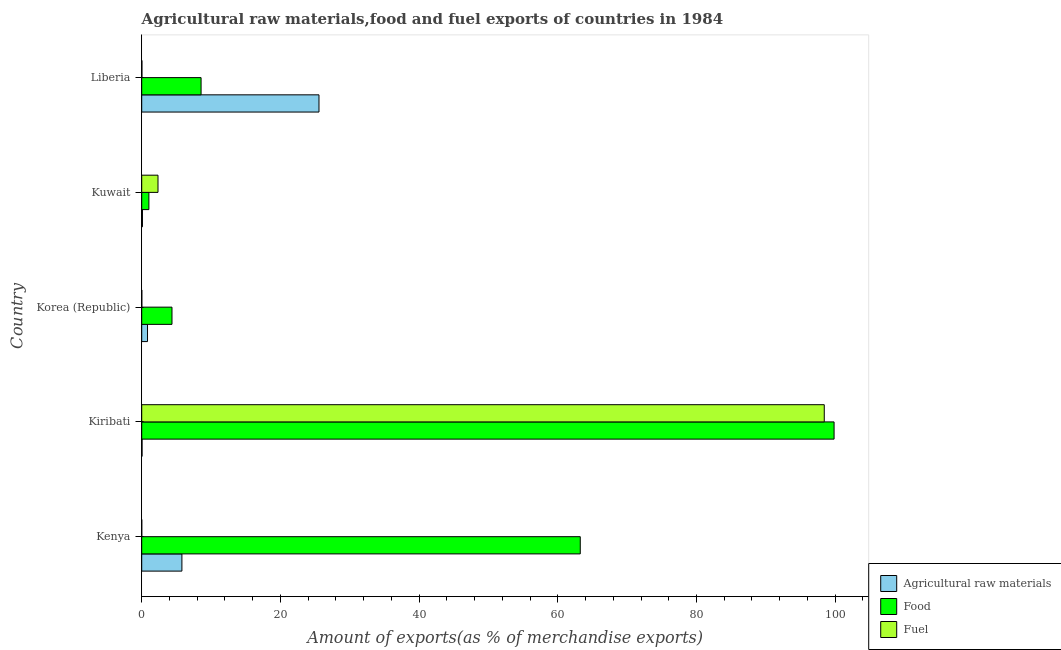Are the number of bars per tick equal to the number of legend labels?
Give a very brief answer. Yes. Are the number of bars on each tick of the Y-axis equal?
Provide a succinct answer. Yes. What is the label of the 1st group of bars from the top?
Provide a succinct answer. Liberia. What is the percentage of food exports in Kenya?
Keep it short and to the point. 63.24. Across all countries, what is the maximum percentage of food exports?
Your answer should be compact. 99.84. Across all countries, what is the minimum percentage of raw materials exports?
Offer a terse response. 0.05. In which country was the percentage of raw materials exports maximum?
Ensure brevity in your answer.  Liberia. In which country was the percentage of raw materials exports minimum?
Provide a succinct answer. Kiribati. What is the total percentage of food exports in the graph?
Offer a terse response. 177.03. What is the difference between the percentage of raw materials exports in Korea (Republic) and that in Kuwait?
Offer a terse response. 0.73. What is the difference between the percentage of raw materials exports in Korea (Republic) and the percentage of food exports in Kiribati?
Make the answer very short. -99. What is the average percentage of food exports per country?
Make the answer very short. 35.41. What is the difference between the percentage of fuel exports and percentage of raw materials exports in Kuwait?
Your response must be concise. 2.24. In how many countries, is the percentage of fuel exports greater than 28 %?
Offer a very short reply. 1. What is the ratio of the percentage of food exports in Korea (Republic) to that in Liberia?
Your response must be concise. 0.51. What is the difference between the highest and the second highest percentage of food exports?
Your answer should be very brief. 36.6. What is the difference between the highest and the lowest percentage of raw materials exports?
Offer a terse response. 25.51. In how many countries, is the percentage of food exports greater than the average percentage of food exports taken over all countries?
Give a very brief answer. 2. Is the sum of the percentage of food exports in Kenya and Korea (Republic) greater than the maximum percentage of raw materials exports across all countries?
Your answer should be very brief. Yes. What does the 3rd bar from the top in Liberia represents?
Your answer should be very brief. Agricultural raw materials. What does the 3rd bar from the bottom in Korea (Republic) represents?
Ensure brevity in your answer.  Fuel. How many bars are there?
Your answer should be very brief. 15. Are all the bars in the graph horizontal?
Give a very brief answer. Yes. How many countries are there in the graph?
Offer a very short reply. 5. Are the values on the major ticks of X-axis written in scientific E-notation?
Make the answer very short. No. Does the graph contain any zero values?
Provide a succinct answer. No. Does the graph contain grids?
Offer a terse response. No. Where does the legend appear in the graph?
Provide a short and direct response. Bottom right. How many legend labels are there?
Your response must be concise. 3. What is the title of the graph?
Provide a succinct answer. Agricultural raw materials,food and fuel exports of countries in 1984. Does "Nuclear sources" appear as one of the legend labels in the graph?
Give a very brief answer. No. What is the label or title of the X-axis?
Provide a short and direct response. Amount of exports(as % of merchandise exports). What is the Amount of exports(as % of merchandise exports) of Agricultural raw materials in Kenya?
Ensure brevity in your answer.  5.79. What is the Amount of exports(as % of merchandise exports) of Food in Kenya?
Give a very brief answer. 63.24. What is the Amount of exports(as % of merchandise exports) in Fuel in Kenya?
Give a very brief answer. 0. What is the Amount of exports(as % of merchandise exports) of Agricultural raw materials in Kiribati?
Provide a short and direct response. 0.05. What is the Amount of exports(as % of merchandise exports) of Food in Kiribati?
Offer a very short reply. 99.84. What is the Amount of exports(as % of merchandise exports) in Fuel in Kiribati?
Your response must be concise. 98.42. What is the Amount of exports(as % of merchandise exports) in Agricultural raw materials in Korea (Republic)?
Offer a terse response. 0.84. What is the Amount of exports(as % of merchandise exports) in Food in Korea (Republic)?
Keep it short and to the point. 4.36. What is the Amount of exports(as % of merchandise exports) of Fuel in Korea (Republic)?
Your response must be concise. 0.01. What is the Amount of exports(as % of merchandise exports) in Agricultural raw materials in Kuwait?
Make the answer very short. 0.11. What is the Amount of exports(as % of merchandise exports) in Food in Kuwait?
Your response must be concise. 1.03. What is the Amount of exports(as % of merchandise exports) in Fuel in Kuwait?
Offer a terse response. 2.35. What is the Amount of exports(as % of merchandise exports) of Agricultural raw materials in Liberia?
Provide a succinct answer. 25.56. What is the Amount of exports(as % of merchandise exports) of Food in Liberia?
Offer a terse response. 8.56. What is the Amount of exports(as % of merchandise exports) in Fuel in Liberia?
Your answer should be compact. 0.03. Across all countries, what is the maximum Amount of exports(as % of merchandise exports) in Agricultural raw materials?
Make the answer very short. 25.56. Across all countries, what is the maximum Amount of exports(as % of merchandise exports) in Food?
Your answer should be compact. 99.84. Across all countries, what is the maximum Amount of exports(as % of merchandise exports) in Fuel?
Your answer should be compact. 98.42. Across all countries, what is the minimum Amount of exports(as % of merchandise exports) of Agricultural raw materials?
Keep it short and to the point. 0.05. Across all countries, what is the minimum Amount of exports(as % of merchandise exports) in Food?
Make the answer very short. 1.03. Across all countries, what is the minimum Amount of exports(as % of merchandise exports) of Fuel?
Give a very brief answer. 0. What is the total Amount of exports(as % of merchandise exports) in Agricultural raw materials in the graph?
Offer a terse response. 32.35. What is the total Amount of exports(as % of merchandise exports) in Food in the graph?
Ensure brevity in your answer.  177.03. What is the total Amount of exports(as % of merchandise exports) in Fuel in the graph?
Ensure brevity in your answer.  100.82. What is the difference between the Amount of exports(as % of merchandise exports) in Agricultural raw materials in Kenya and that in Kiribati?
Offer a very short reply. 5.75. What is the difference between the Amount of exports(as % of merchandise exports) of Food in Kenya and that in Kiribati?
Keep it short and to the point. -36.6. What is the difference between the Amount of exports(as % of merchandise exports) of Fuel in Kenya and that in Kiribati?
Your answer should be compact. -98.42. What is the difference between the Amount of exports(as % of merchandise exports) of Agricultural raw materials in Kenya and that in Korea (Republic)?
Keep it short and to the point. 4.96. What is the difference between the Amount of exports(as % of merchandise exports) in Food in Kenya and that in Korea (Republic)?
Provide a short and direct response. 58.87. What is the difference between the Amount of exports(as % of merchandise exports) of Fuel in Kenya and that in Korea (Republic)?
Your answer should be compact. -0.01. What is the difference between the Amount of exports(as % of merchandise exports) of Agricultural raw materials in Kenya and that in Kuwait?
Give a very brief answer. 5.69. What is the difference between the Amount of exports(as % of merchandise exports) in Food in Kenya and that in Kuwait?
Ensure brevity in your answer.  62.2. What is the difference between the Amount of exports(as % of merchandise exports) in Fuel in Kenya and that in Kuwait?
Your answer should be compact. -2.34. What is the difference between the Amount of exports(as % of merchandise exports) in Agricultural raw materials in Kenya and that in Liberia?
Your answer should be very brief. -19.77. What is the difference between the Amount of exports(as % of merchandise exports) of Food in Kenya and that in Liberia?
Give a very brief answer. 54.68. What is the difference between the Amount of exports(as % of merchandise exports) in Fuel in Kenya and that in Liberia?
Make the answer very short. -0.02. What is the difference between the Amount of exports(as % of merchandise exports) in Agricultural raw materials in Kiribati and that in Korea (Republic)?
Ensure brevity in your answer.  -0.79. What is the difference between the Amount of exports(as % of merchandise exports) in Food in Kiribati and that in Korea (Republic)?
Your answer should be compact. 95.47. What is the difference between the Amount of exports(as % of merchandise exports) in Fuel in Kiribati and that in Korea (Republic)?
Offer a terse response. 98.41. What is the difference between the Amount of exports(as % of merchandise exports) of Agricultural raw materials in Kiribati and that in Kuwait?
Your answer should be compact. -0.06. What is the difference between the Amount of exports(as % of merchandise exports) of Food in Kiribati and that in Kuwait?
Provide a short and direct response. 98.8. What is the difference between the Amount of exports(as % of merchandise exports) of Fuel in Kiribati and that in Kuwait?
Your answer should be compact. 96.08. What is the difference between the Amount of exports(as % of merchandise exports) of Agricultural raw materials in Kiribati and that in Liberia?
Your answer should be very brief. -25.51. What is the difference between the Amount of exports(as % of merchandise exports) in Food in Kiribati and that in Liberia?
Provide a succinct answer. 91.28. What is the difference between the Amount of exports(as % of merchandise exports) in Fuel in Kiribati and that in Liberia?
Your response must be concise. 98.39. What is the difference between the Amount of exports(as % of merchandise exports) in Agricultural raw materials in Korea (Republic) and that in Kuwait?
Ensure brevity in your answer.  0.73. What is the difference between the Amount of exports(as % of merchandise exports) of Food in Korea (Republic) and that in Kuwait?
Offer a very short reply. 3.33. What is the difference between the Amount of exports(as % of merchandise exports) in Fuel in Korea (Republic) and that in Kuwait?
Provide a succinct answer. -2.33. What is the difference between the Amount of exports(as % of merchandise exports) of Agricultural raw materials in Korea (Republic) and that in Liberia?
Ensure brevity in your answer.  -24.72. What is the difference between the Amount of exports(as % of merchandise exports) of Food in Korea (Republic) and that in Liberia?
Provide a short and direct response. -4.2. What is the difference between the Amount of exports(as % of merchandise exports) in Fuel in Korea (Republic) and that in Liberia?
Your response must be concise. -0.02. What is the difference between the Amount of exports(as % of merchandise exports) in Agricultural raw materials in Kuwait and that in Liberia?
Keep it short and to the point. -25.45. What is the difference between the Amount of exports(as % of merchandise exports) of Food in Kuwait and that in Liberia?
Make the answer very short. -7.53. What is the difference between the Amount of exports(as % of merchandise exports) in Fuel in Kuwait and that in Liberia?
Your answer should be very brief. 2.32. What is the difference between the Amount of exports(as % of merchandise exports) of Agricultural raw materials in Kenya and the Amount of exports(as % of merchandise exports) of Food in Kiribati?
Ensure brevity in your answer.  -94.04. What is the difference between the Amount of exports(as % of merchandise exports) of Agricultural raw materials in Kenya and the Amount of exports(as % of merchandise exports) of Fuel in Kiribati?
Give a very brief answer. -92.63. What is the difference between the Amount of exports(as % of merchandise exports) of Food in Kenya and the Amount of exports(as % of merchandise exports) of Fuel in Kiribati?
Your response must be concise. -35.19. What is the difference between the Amount of exports(as % of merchandise exports) in Agricultural raw materials in Kenya and the Amount of exports(as % of merchandise exports) in Food in Korea (Republic)?
Make the answer very short. 1.43. What is the difference between the Amount of exports(as % of merchandise exports) of Agricultural raw materials in Kenya and the Amount of exports(as % of merchandise exports) of Fuel in Korea (Republic)?
Provide a succinct answer. 5.78. What is the difference between the Amount of exports(as % of merchandise exports) in Food in Kenya and the Amount of exports(as % of merchandise exports) in Fuel in Korea (Republic)?
Keep it short and to the point. 63.23. What is the difference between the Amount of exports(as % of merchandise exports) of Agricultural raw materials in Kenya and the Amount of exports(as % of merchandise exports) of Food in Kuwait?
Offer a very short reply. 4.76. What is the difference between the Amount of exports(as % of merchandise exports) in Agricultural raw materials in Kenya and the Amount of exports(as % of merchandise exports) in Fuel in Kuwait?
Give a very brief answer. 3.45. What is the difference between the Amount of exports(as % of merchandise exports) in Food in Kenya and the Amount of exports(as % of merchandise exports) in Fuel in Kuwait?
Provide a short and direct response. 60.89. What is the difference between the Amount of exports(as % of merchandise exports) of Agricultural raw materials in Kenya and the Amount of exports(as % of merchandise exports) of Food in Liberia?
Offer a very short reply. -2.77. What is the difference between the Amount of exports(as % of merchandise exports) of Agricultural raw materials in Kenya and the Amount of exports(as % of merchandise exports) of Fuel in Liberia?
Your response must be concise. 5.77. What is the difference between the Amount of exports(as % of merchandise exports) in Food in Kenya and the Amount of exports(as % of merchandise exports) in Fuel in Liberia?
Offer a very short reply. 63.21. What is the difference between the Amount of exports(as % of merchandise exports) of Agricultural raw materials in Kiribati and the Amount of exports(as % of merchandise exports) of Food in Korea (Republic)?
Offer a very short reply. -4.32. What is the difference between the Amount of exports(as % of merchandise exports) in Agricultural raw materials in Kiribati and the Amount of exports(as % of merchandise exports) in Fuel in Korea (Republic)?
Keep it short and to the point. 0.04. What is the difference between the Amount of exports(as % of merchandise exports) of Food in Kiribati and the Amount of exports(as % of merchandise exports) of Fuel in Korea (Republic)?
Your answer should be very brief. 99.83. What is the difference between the Amount of exports(as % of merchandise exports) in Agricultural raw materials in Kiribati and the Amount of exports(as % of merchandise exports) in Food in Kuwait?
Provide a short and direct response. -0.99. What is the difference between the Amount of exports(as % of merchandise exports) of Agricultural raw materials in Kiribati and the Amount of exports(as % of merchandise exports) of Fuel in Kuwait?
Offer a very short reply. -2.3. What is the difference between the Amount of exports(as % of merchandise exports) of Food in Kiribati and the Amount of exports(as % of merchandise exports) of Fuel in Kuwait?
Your answer should be very brief. 97.49. What is the difference between the Amount of exports(as % of merchandise exports) of Agricultural raw materials in Kiribati and the Amount of exports(as % of merchandise exports) of Food in Liberia?
Offer a very short reply. -8.51. What is the difference between the Amount of exports(as % of merchandise exports) of Food in Kiribati and the Amount of exports(as % of merchandise exports) of Fuel in Liberia?
Your response must be concise. 99.81. What is the difference between the Amount of exports(as % of merchandise exports) of Agricultural raw materials in Korea (Republic) and the Amount of exports(as % of merchandise exports) of Food in Kuwait?
Keep it short and to the point. -0.2. What is the difference between the Amount of exports(as % of merchandise exports) of Agricultural raw materials in Korea (Republic) and the Amount of exports(as % of merchandise exports) of Fuel in Kuwait?
Offer a terse response. -1.51. What is the difference between the Amount of exports(as % of merchandise exports) of Food in Korea (Republic) and the Amount of exports(as % of merchandise exports) of Fuel in Kuwait?
Ensure brevity in your answer.  2.02. What is the difference between the Amount of exports(as % of merchandise exports) of Agricultural raw materials in Korea (Republic) and the Amount of exports(as % of merchandise exports) of Food in Liberia?
Your answer should be very brief. -7.72. What is the difference between the Amount of exports(as % of merchandise exports) in Agricultural raw materials in Korea (Republic) and the Amount of exports(as % of merchandise exports) in Fuel in Liberia?
Provide a succinct answer. 0.81. What is the difference between the Amount of exports(as % of merchandise exports) of Food in Korea (Republic) and the Amount of exports(as % of merchandise exports) of Fuel in Liberia?
Offer a very short reply. 4.34. What is the difference between the Amount of exports(as % of merchandise exports) in Agricultural raw materials in Kuwait and the Amount of exports(as % of merchandise exports) in Food in Liberia?
Your answer should be very brief. -8.45. What is the difference between the Amount of exports(as % of merchandise exports) of Agricultural raw materials in Kuwait and the Amount of exports(as % of merchandise exports) of Fuel in Liberia?
Offer a terse response. 0.08. What is the difference between the Amount of exports(as % of merchandise exports) of Food in Kuwait and the Amount of exports(as % of merchandise exports) of Fuel in Liberia?
Your answer should be compact. 1.01. What is the average Amount of exports(as % of merchandise exports) in Agricultural raw materials per country?
Offer a terse response. 6.47. What is the average Amount of exports(as % of merchandise exports) in Food per country?
Provide a short and direct response. 35.41. What is the average Amount of exports(as % of merchandise exports) of Fuel per country?
Provide a succinct answer. 20.16. What is the difference between the Amount of exports(as % of merchandise exports) of Agricultural raw materials and Amount of exports(as % of merchandise exports) of Food in Kenya?
Offer a terse response. -57.44. What is the difference between the Amount of exports(as % of merchandise exports) of Agricultural raw materials and Amount of exports(as % of merchandise exports) of Fuel in Kenya?
Your answer should be very brief. 5.79. What is the difference between the Amount of exports(as % of merchandise exports) in Food and Amount of exports(as % of merchandise exports) in Fuel in Kenya?
Give a very brief answer. 63.23. What is the difference between the Amount of exports(as % of merchandise exports) in Agricultural raw materials and Amount of exports(as % of merchandise exports) in Food in Kiribati?
Your answer should be very brief. -99.79. What is the difference between the Amount of exports(as % of merchandise exports) of Agricultural raw materials and Amount of exports(as % of merchandise exports) of Fuel in Kiribati?
Your answer should be very brief. -98.37. What is the difference between the Amount of exports(as % of merchandise exports) in Food and Amount of exports(as % of merchandise exports) in Fuel in Kiribati?
Provide a short and direct response. 1.41. What is the difference between the Amount of exports(as % of merchandise exports) in Agricultural raw materials and Amount of exports(as % of merchandise exports) in Food in Korea (Republic)?
Your response must be concise. -3.53. What is the difference between the Amount of exports(as % of merchandise exports) of Agricultural raw materials and Amount of exports(as % of merchandise exports) of Fuel in Korea (Republic)?
Provide a short and direct response. 0.82. What is the difference between the Amount of exports(as % of merchandise exports) in Food and Amount of exports(as % of merchandise exports) in Fuel in Korea (Republic)?
Offer a very short reply. 4.35. What is the difference between the Amount of exports(as % of merchandise exports) in Agricultural raw materials and Amount of exports(as % of merchandise exports) in Food in Kuwait?
Your answer should be very brief. -0.93. What is the difference between the Amount of exports(as % of merchandise exports) of Agricultural raw materials and Amount of exports(as % of merchandise exports) of Fuel in Kuwait?
Ensure brevity in your answer.  -2.24. What is the difference between the Amount of exports(as % of merchandise exports) in Food and Amount of exports(as % of merchandise exports) in Fuel in Kuwait?
Give a very brief answer. -1.31. What is the difference between the Amount of exports(as % of merchandise exports) in Agricultural raw materials and Amount of exports(as % of merchandise exports) in Food in Liberia?
Provide a short and direct response. 17. What is the difference between the Amount of exports(as % of merchandise exports) of Agricultural raw materials and Amount of exports(as % of merchandise exports) of Fuel in Liberia?
Keep it short and to the point. 25.53. What is the difference between the Amount of exports(as % of merchandise exports) in Food and Amount of exports(as % of merchandise exports) in Fuel in Liberia?
Your response must be concise. 8.53. What is the ratio of the Amount of exports(as % of merchandise exports) in Agricultural raw materials in Kenya to that in Kiribati?
Provide a succinct answer. 118.35. What is the ratio of the Amount of exports(as % of merchandise exports) in Food in Kenya to that in Kiribati?
Ensure brevity in your answer.  0.63. What is the ratio of the Amount of exports(as % of merchandise exports) in Fuel in Kenya to that in Kiribati?
Make the answer very short. 0. What is the ratio of the Amount of exports(as % of merchandise exports) in Agricultural raw materials in Kenya to that in Korea (Republic)?
Provide a short and direct response. 6.93. What is the ratio of the Amount of exports(as % of merchandise exports) of Food in Kenya to that in Korea (Republic)?
Your answer should be compact. 14.49. What is the ratio of the Amount of exports(as % of merchandise exports) of Fuel in Kenya to that in Korea (Republic)?
Provide a short and direct response. 0.33. What is the ratio of the Amount of exports(as % of merchandise exports) of Agricultural raw materials in Kenya to that in Kuwait?
Your response must be concise. 54.43. What is the ratio of the Amount of exports(as % of merchandise exports) in Food in Kenya to that in Kuwait?
Make the answer very short. 61.13. What is the ratio of the Amount of exports(as % of merchandise exports) of Fuel in Kenya to that in Kuwait?
Ensure brevity in your answer.  0. What is the ratio of the Amount of exports(as % of merchandise exports) of Agricultural raw materials in Kenya to that in Liberia?
Your response must be concise. 0.23. What is the ratio of the Amount of exports(as % of merchandise exports) of Food in Kenya to that in Liberia?
Provide a succinct answer. 7.39. What is the ratio of the Amount of exports(as % of merchandise exports) in Fuel in Kenya to that in Liberia?
Your response must be concise. 0.14. What is the ratio of the Amount of exports(as % of merchandise exports) of Agricultural raw materials in Kiribati to that in Korea (Republic)?
Your answer should be compact. 0.06. What is the ratio of the Amount of exports(as % of merchandise exports) of Food in Kiribati to that in Korea (Republic)?
Your response must be concise. 22.88. What is the ratio of the Amount of exports(as % of merchandise exports) of Fuel in Kiribati to that in Korea (Republic)?
Your response must be concise. 7798.51. What is the ratio of the Amount of exports(as % of merchandise exports) in Agricultural raw materials in Kiribati to that in Kuwait?
Ensure brevity in your answer.  0.46. What is the ratio of the Amount of exports(as % of merchandise exports) of Food in Kiribati to that in Kuwait?
Your answer should be very brief. 96.51. What is the ratio of the Amount of exports(as % of merchandise exports) in Fuel in Kiribati to that in Kuwait?
Your answer should be compact. 41.93. What is the ratio of the Amount of exports(as % of merchandise exports) in Agricultural raw materials in Kiribati to that in Liberia?
Make the answer very short. 0. What is the ratio of the Amount of exports(as % of merchandise exports) in Food in Kiribati to that in Liberia?
Your answer should be very brief. 11.66. What is the ratio of the Amount of exports(as % of merchandise exports) in Fuel in Kiribati to that in Liberia?
Offer a very short reply. 3401.56. What is the ratio of the Amount of exports(as % of merchandise exports) in Agricultural raw materials in Korea (Republic) to that in Kuwait?
Give a very brief answer. 7.85. What is the ratio of the Amount of exports(as % of merchandise exports) in Food in Korea (Republic) to that in Kuwait?
Your answer should be compact. 4.22. What is the ratio of the Amount of exports(as % of merchandise exports) in Fuel in Korea (Republic) to that in Kuwait?
Your response must be concise. 0.01. What is the ratio of the Amount of exports(as % of merchandise exports) in Agricultural raw materials in Korea (Republic) to that in Liberia?
Make the answer very short. 0.03. What is the ratio of the Amount of exports(as % of merchandise exports) in Food in Korea (Republic) to that in Liberia?
Ensure brevity in your answer.  0.51. What is the ratio of the Amount of exports(as % of merchandise exports) in Fuel in Korea (Republic) to that in Liberia?
Keep it short and to the point. 0.44. What is the ratio of the Amount of exports(as % of merchandise exports) in Agricultural raw materials in Kuwait to that in Liberia?
Give a very brief answer. 0. What is the ratio of the Amount of exports(as % of merchandise exports) of Food in Kuwait to that in Liberia?
Keep it short and to the point. 0.12. What is the ratio of the Amount of exports(as % of merchandise exports) of Fuel in Kuwait to that in Liberia?
Keep it short and to the point. 81.13. What is the difference between the highest and the second highest Amount of exports(as % of merchandise exports) of Agricultural raw materials?
Keep it short and to the point. 19.77. What is the difference between the highest and the second highest Amount of exports(as % of merchandise exports) of Food?
Ensure brevity in your answer.  36.6. What is the difference between the highest and the second highest Amount of exports(as % of merchandise exports) of Fuel?
Provide a succinct answer. 96.08. What is the difference between the highest and the lowest Amount of exports(as % of merchandise exports) in Agricultural raw materials?
Offer a very short reply. 25.51. What is the difference between the highest and the lowest Amount of exports(as % of merchandise exports) of Food?
Your answer should be very brief. 98.8. What is the difference between the highest and the lowest Amount of exports(as % of merchandise exports) of Fuel?
Your response must be concise. 98.42. 